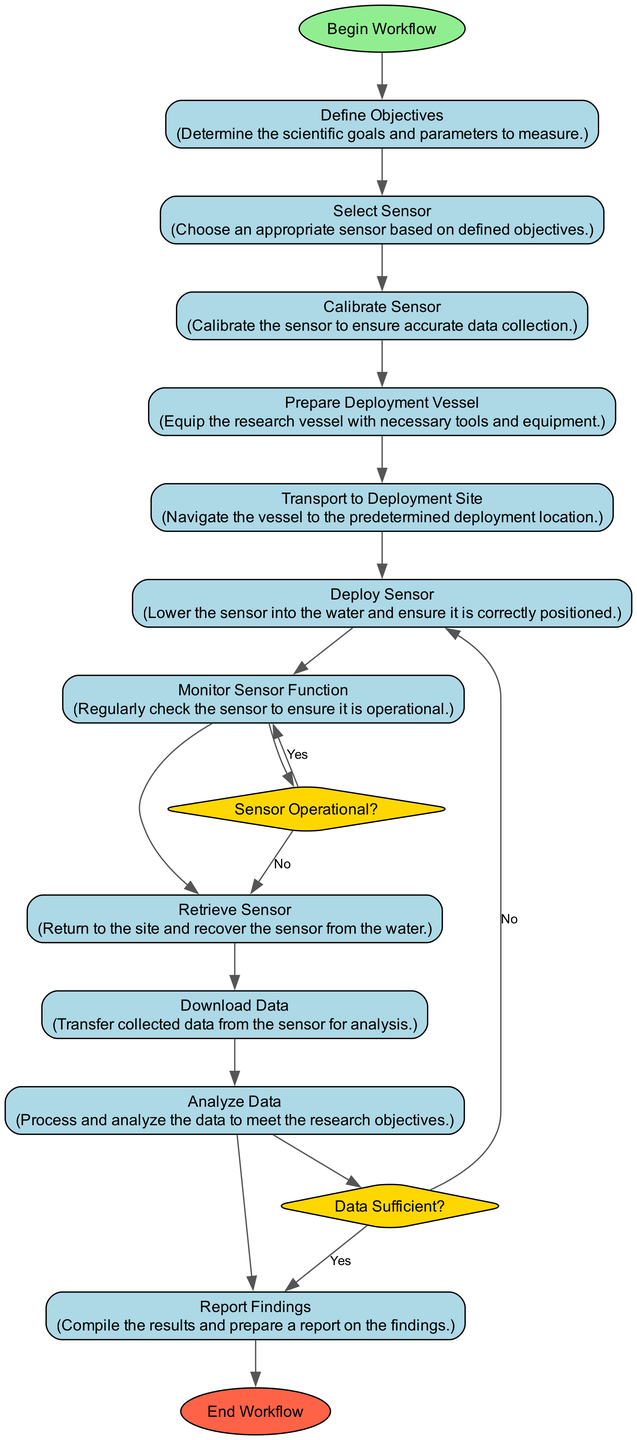What is the first activity in the workflow? The first activity listed in the diagram is "Define Objectives," which is indicated as the starting point of the workflow.
Answer: Define Objectives What shape is used for decision points in the diagram? The diagram indicates that decision points are represented with diamond shapes, which is a standard representation for decisions in flowcharts and activity diagrams.
Answer: Diamond How many activities are there in total? By counting the activities listed in the diagram, we find that there are 11 activity nodes in total.
Answer: 11 What happens after the "Deploy Sensor" activity? After the "Deploy Sensor" activity, the workflow checks the decision point "Sensor Operational?" to verify if the sensor is functioning correctly. If it is operational, it proceeds to "Monitor Sensor Function." If not, it returns to "Deploy Sensor."
Answer: Monitor Sensor Function What is the final step in the workflow? The final step in the workflow is "End Workflow," which concludes the entire deployment and retrieval process.
Answer: End Workflow Which activity follows "Download Data"? The activity that follows "Download Data" is "Analyze Data," where the collected data is processed and examined to meet the research objectives.
Answer: Analyze Data What decision point checks the sufficiency of the collected data? The decision point that checks if the data collected is sufficient is named "Data Sufficient?" This determines whether the analysis can proceed based on the data received.
Answer: Data Sufficient Which activity requires calibration of the sensor? The activity that requires the calibration of the sensor is "Calibrate Sensor," which ensures that the sensor will collect accurate data for the research objectives.
Answer: Calibrate Sensor If the sensor is not operational, which activity does the workflow return to? If the sensor is not found to be operational during monitoring, the workflow returns to the "Deploy Sensor" activity to re-check or reposition the sensor.
Answer: Deploy Sensor 